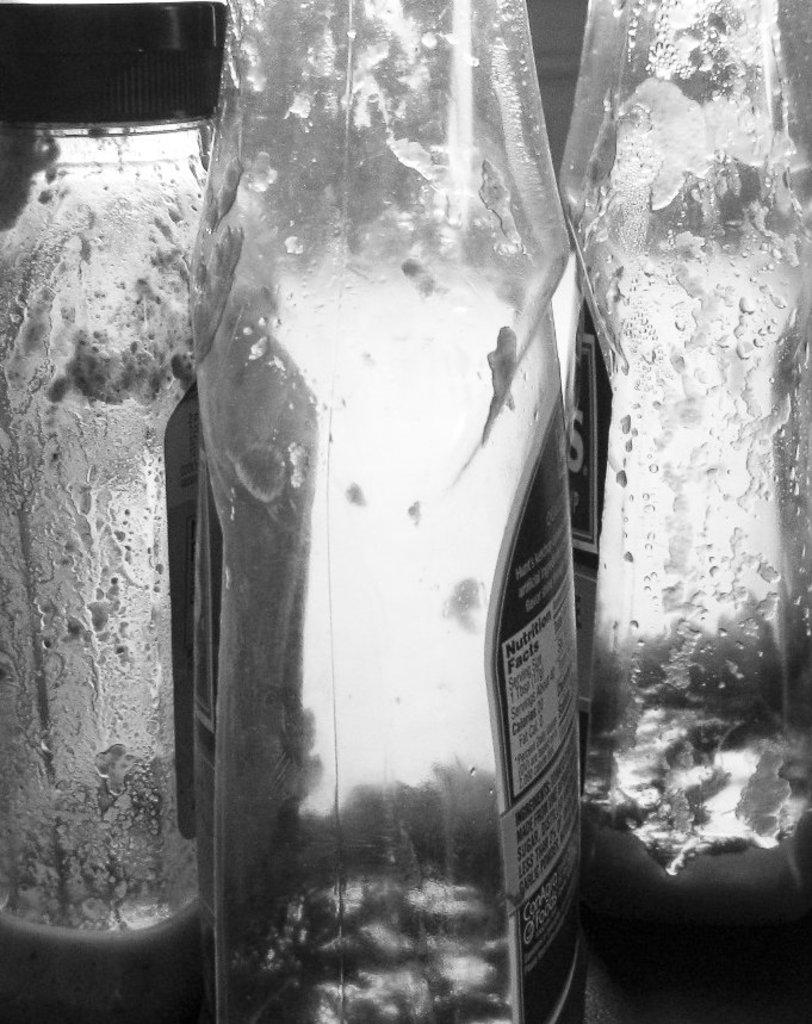How many bottles are visible in the image? There are three bottles in the image. What color are the bottles in the image? The bottles are in black and white. Are the bottles filled with any liquid or substance? No, the bottles are empty. What can be found on the surface of each bottle? Each bottle has a label. What information is provided on the labels? There is text printed on the labels. What type of wren can be seen perched on the bottle in the image? There are no birds, including wrens, present in the image. 